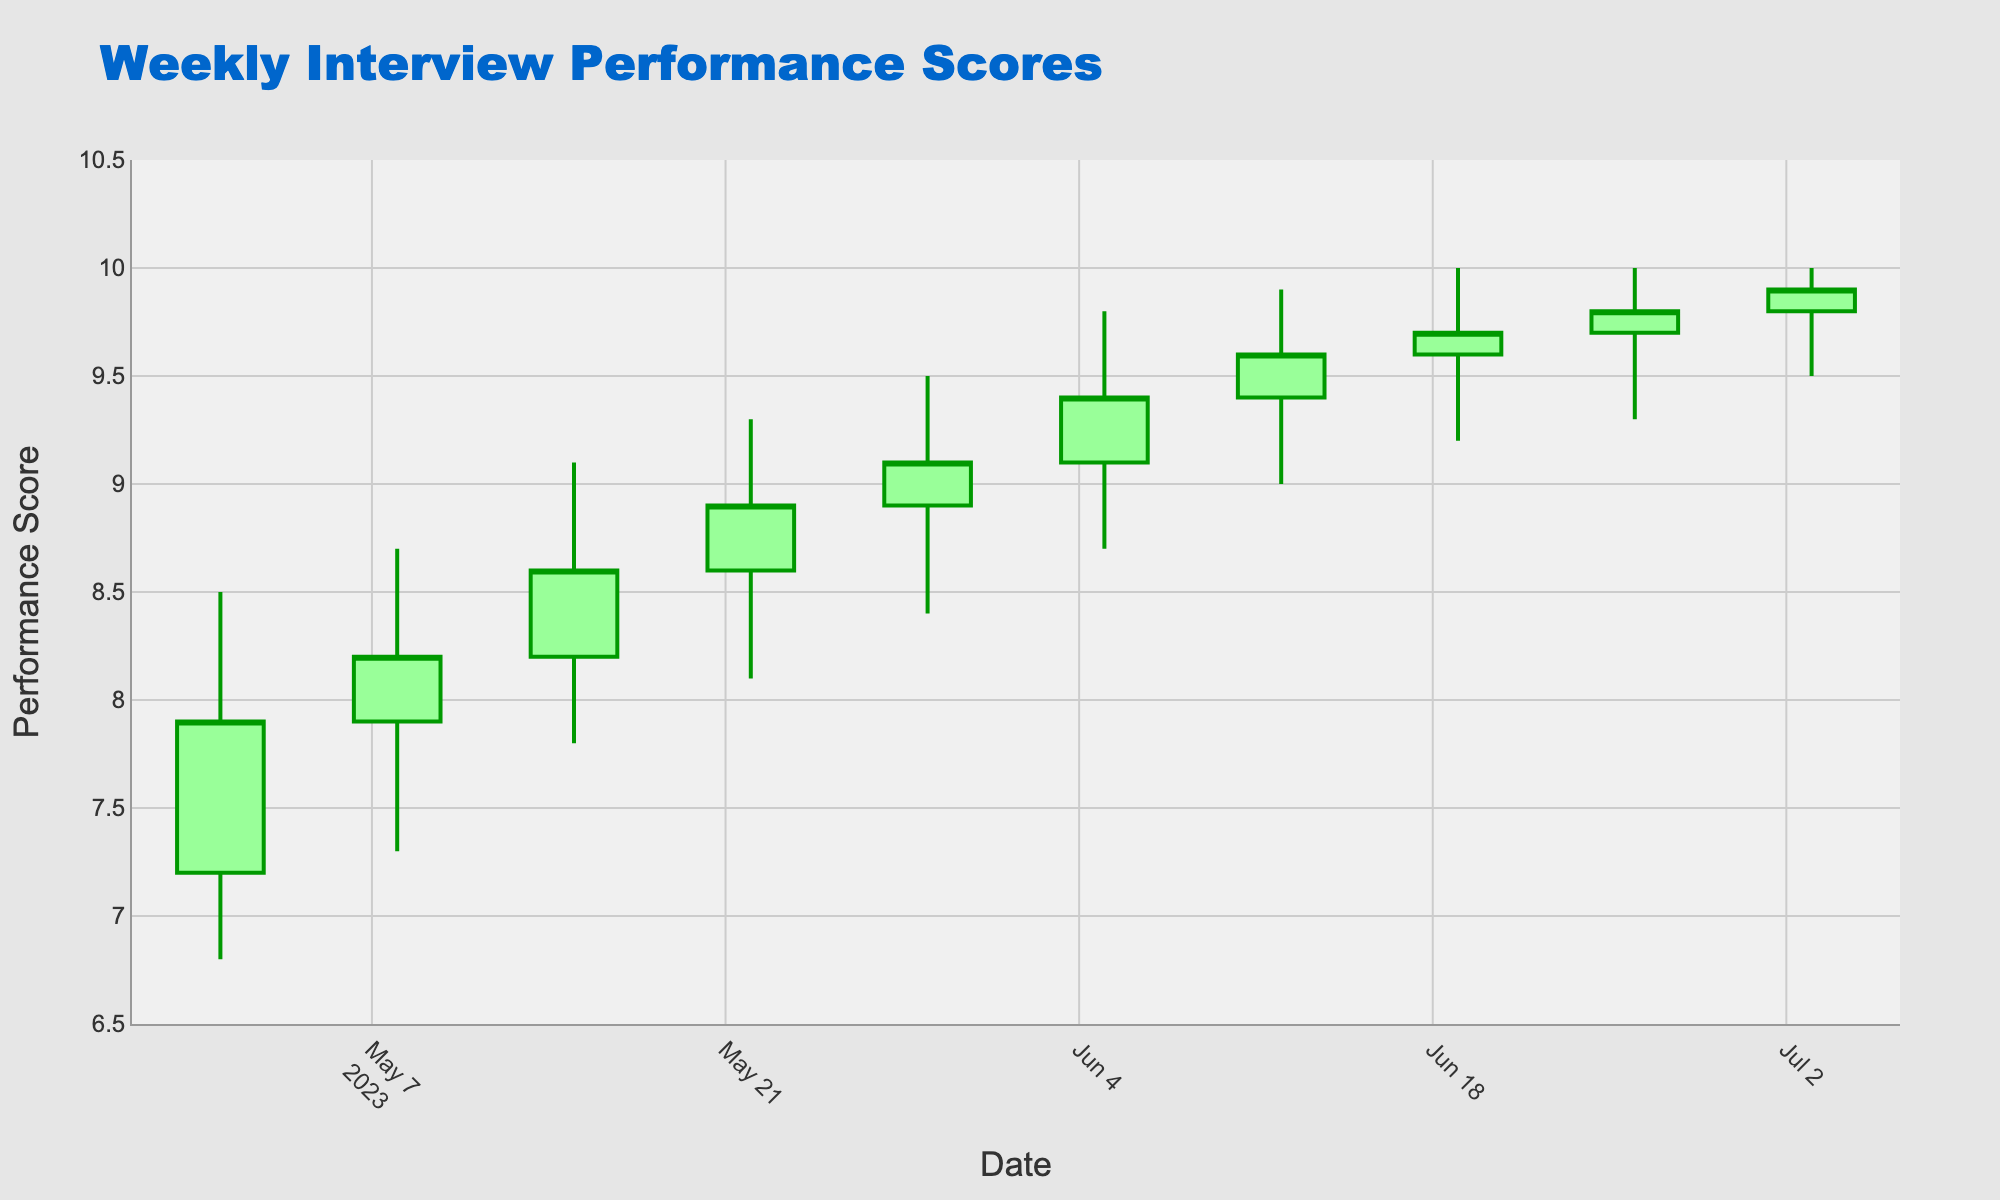What is the title of the figure? The title of the figure is written at the top of the chart and it summarizes the content displayed. In this case, the title is "Weekly Interview Performance Scores".
Answer: Weekly Interview Performance Scores What do the x-axis and y-axis represent? The x-axis represents the timeline of dates, while the y-axis indicates the performance scores of the candidates assessed on communication skills.
Answer: Dates and Performance Scores How many weeks of data are represented in the figure? Count the number of distinct candlestick entries along the x-axis to determine the number of weeks. There are 10 candlestick entries, corresponding to 10 weeks.
Answer: 10 weeks Which week had the highest peak performance score? The week of 2023-06-19 had the highest high value of 10.0, as observed from the highest point on the y-axis that the candlesticks reach.
Answer: 2023-06-19 What is the general trend of the closing values over the weeks? Observing the positions of the closing marks on the candlesticks, the general trend is upward, starting from 7.9 on 2023-05-01 and ending at 9.9 on 2023-07-03.
Answer: Upward Comparison: Which week had a higher closing value, 2023-05-15 or 2023-06-12? By comparing the closing values of the two weeks, 2023-05-15 has a closing value of 8.6 while 2023-06-12 has a closing value of 9.6. Therefore, 2023-06-12 had a higher closing value.
Answer: 2023-06-12 What is the median high value across all weeks? Listing out all the high values (8.5, 8.7, 9.1, 9.3, 9.5, 9.8, 9.9, 10.0, 10.0, 10.0), the median is the middle value when they are ordered. With 10 values, the median is the average of 9.5 and 9.8, which is (9.5 + 9.8) / 2 = 9.65.
Answer: 9.65 Which week had the largest range between high and low values? Calculate the range for each week by subtracting the low value from the high value. The largest range is found in the week of 2023-05-15, having a high of 9.1 and a low of 7.8, giving a range of 9.1 - 7.8 = 1.3.
Answer: 2023-05-15 From which week to which week did the closing value consistently increase? Starting from week 2023-05-01 with a closing of 7.9, the closing value consistently increased until 2023-07-03, reaching 9.9. Check each week's closing value to ensure a consistent increase.
Answer: 2023-05-01 to 2023-07-03 Which week experienced both the highest opening value and the highest closing value? The week of 2023-07-03 experienced the highest opening value of 9.8 and also the highest closing value of 9.9, as observed from the topmost positions of the opening and closing points on the y-axis for that week.
Answer: 2023-07-03 